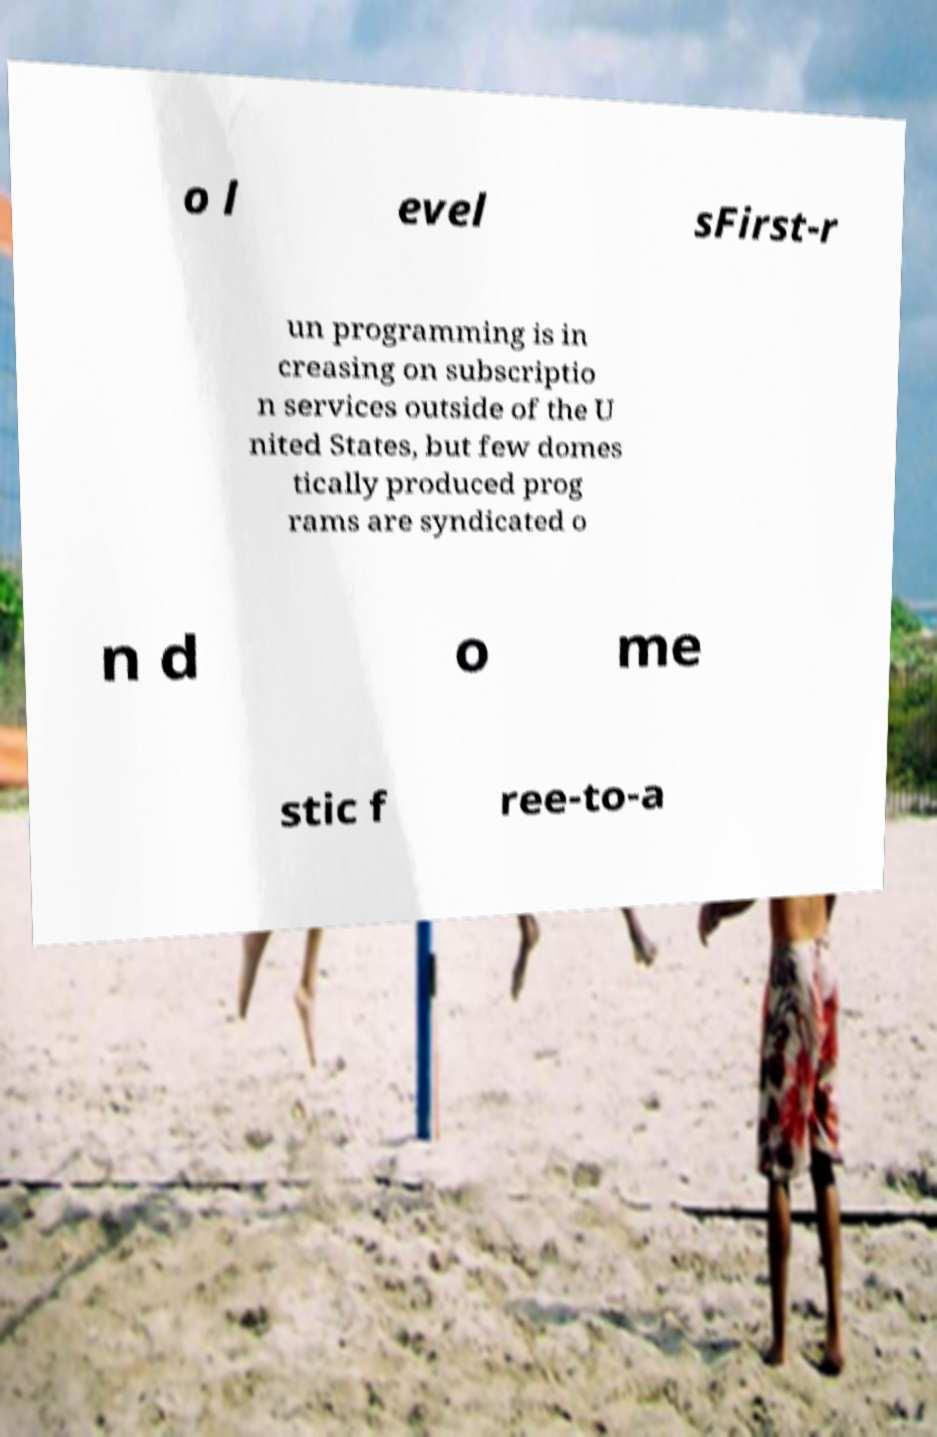Please identify and transcribe the text found in this image. o l evel sFirst-r un programming is in creasing on subscriptio n services outside of the U nited States, but few domes tically produced prog rams are syndicated o n d o me stic f ree-to-a 